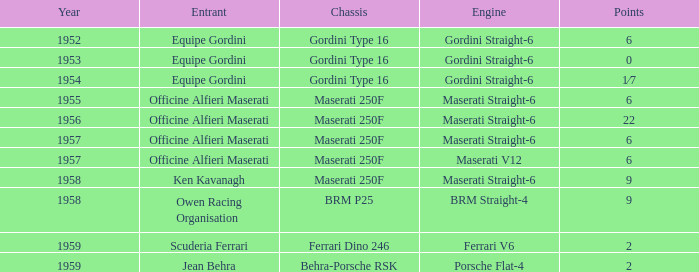What year engine does a ferrari v6 have? 1959.0. 